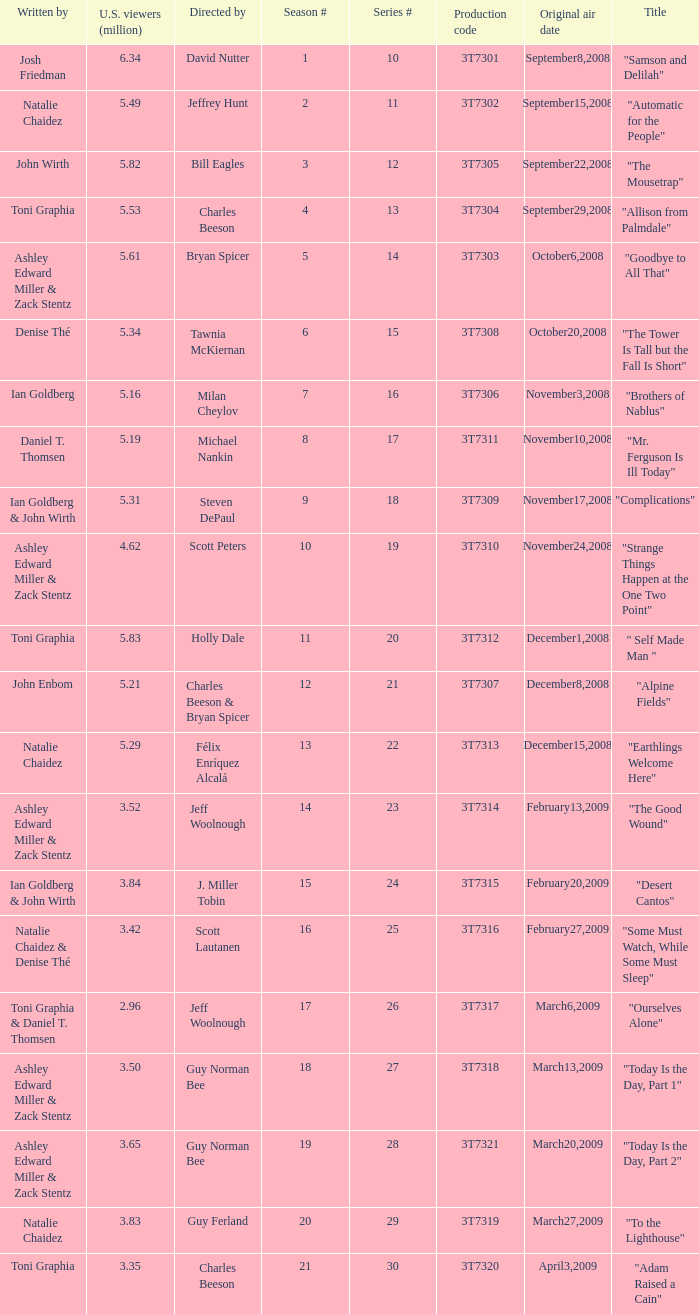Would you mind parsing the complete table? {'header': ['Written by', 'U.S. viewers (million)', 'Directed by', 'Season #', 'Series #', 'Production code', 'Original air date', 'Title'], 'rows': [['Josh Friedman', '6.34', 'David Nutter', '1', '10', '3T7301', 'September8,2008', '"Samson and Delilah"'], ['Natalie Chaidez', '5.49', 'Jeffrey Hunt', '2', '11', '3T7302', 'September15,2008', '"Automatic for the People"'], ['John Wirth', '5.82', 'Bill Eagles', '3', '12', '3T7305', 'September22,2008', '"The Mousetrap"'], ['Toni Graphia', '5.53', 'Charles Beeson', '4', '13', '3T7304', 'September29,2008', '"Allison from Palmdale"'], ['Ashley Edward Miller & Zack Stentz', '5.61', 'Bryan Spicer', '5', '14', '3T7303', 'October6,2008', '"Goodbye to All That"'], ['Denise Thé', '5.34', 'Tawnia McKiernan', '6', '15', '3T7308', 'October20,2008', '"The Tower Is Tall but the Fall Is Short"'], ['Ian Goldberg', '5.16', 'Milan Cheylov', '7', '16', '3T7306', 'November3,2008', '"Brothers of Nablus"'], ['Daniel T. Thomsen', '5.19', 'Michael Nankin', '8', '17', '3T7311', 'November10,2008', '"Mr. Ferguson Is Ill Today"'], ['Ian Goldberg & John Wirth', '5.31', 'Steven DePaul', '9', '18', '3T7309', 'November17,2008', '"Complications"'], ['Ashley Edward Miller & Zack Stentz', '4.62', 'Scott Peters', '10', '19', '3T7310', 'November24,2008', '"Strange Things Happen at the One Two Point"'], ['Toni Graphia', '5.83', 'Holly Dale', '11', '20', '3T7312', 'December1,2008', '" Self Made Man "'], ['John Enbom', '5.21', 'Charles Beeson & Bryan Spicer', '12', '21', '3T7307', 'December8,2008', '"Alpine Fields"'], ['Natalie Chaidez', '5.29', 'Félix Enríquez Alcalá', '13', '22', '3T7313', 'December15,2008', '"Earthlings Welcome Here"'], ['Ashley Edward Miller & Zack Stentz', '3.52', 'Jeff Woolnough', '14', '23', '3T7314', 'February13,2009', '"The Good Wound"'], ['Ian Goldberg & John Wirth', '3.84', 'J. Miller Tobin', '15', '24', '3T7315', 'February20,2009', '"Desert Cantos"'], ['Natalie Chaidez & Denise Thé', '3.42', 'Scott Lautanen', '16', '25', '3T7316', 'February27,2009', '"Some Must Watch, While Some Must Sleep"'], ['Toni Graphia & Daniel T. Thomsen', '2.96', 'Jeff Woolnough', '17', '26', '3T7317', 'March6,2009', '"Ourselves Alone"'], ['Ashley Edward Miller & Zack Stentz', '3.50', 'Guy Norman Bee', '18', '27', '3T7318', 'March13,2009', '"Today Is the Day, Part 1"'], ['Ashley Edward Miller & Zack Stentz', '3.65', 'Guy Norman Bee', '19', '28', '3T7321', 'March20,2009', '"Today Is the Day, Part 2"'], ['Natalie Chaidez', '3.83', 'Guy Ferland', '20', '29', '3T7319', 'March27,2009', '"To the Lighthouse"'], ['Toni Graphia', '3.35', 'Charles Beeson', '21', '30', '3T7320', 'April3,2009', '"Adam Raised a Cain"']]} Which episode number was directed by Bill Eagles? 12.0. 